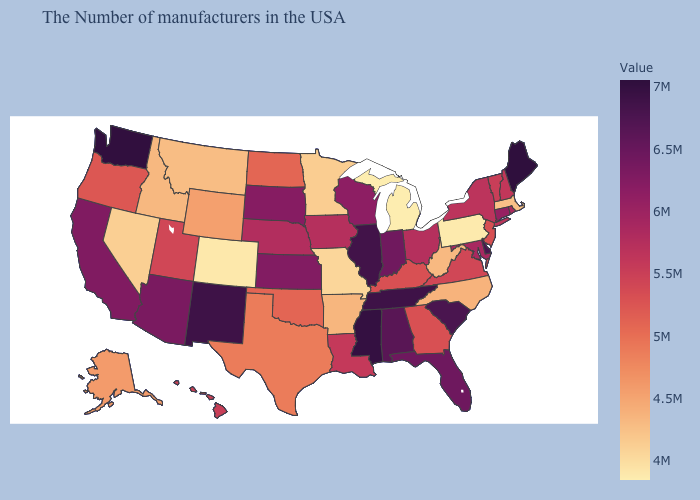Does Montana have the highest value in the West?
Write a very short answer. No. Is the legend a continuous bar?
Quick response, please. Yes. Does Washington have the highest value in the West?
Quick response, please. Yes. Does Maine have the highest value in the Northeast?
Short answer required. Yes. Which states hav the highest value in the South?
Be succinct. Mississippi. Does the map have missing data?
Keep it brief. No. 